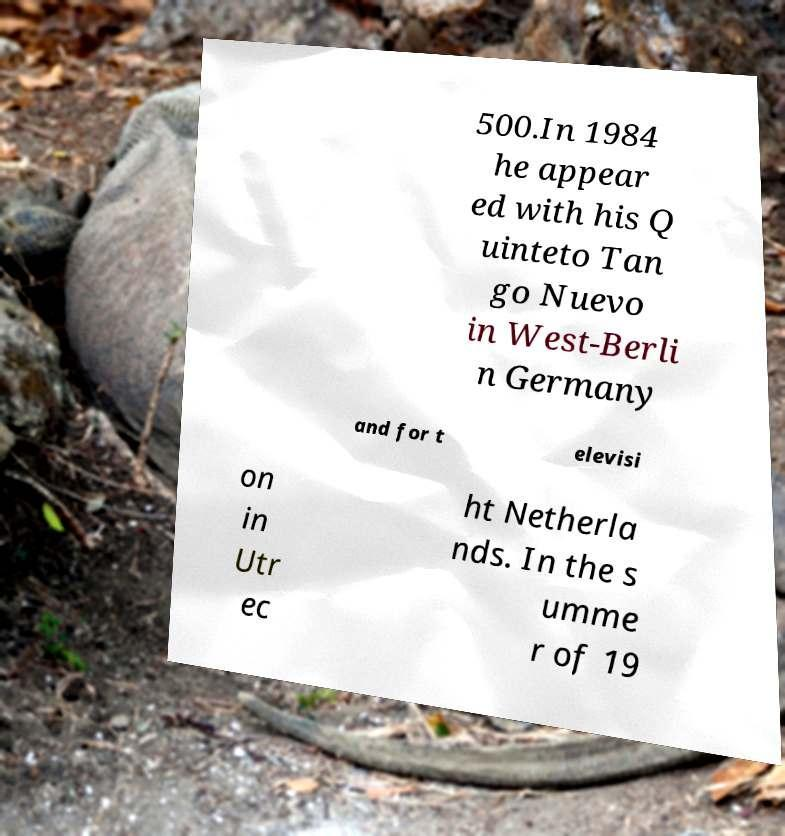Could you assist in decoding the text presented in this image and type it out clearly? 500.In 1984 he appear ed with his Q uinteto Tan go Nuevo in West-Berli n Germany and for t elevisi on in Utr ec ht Netherla nds. In the s umme r of 19 